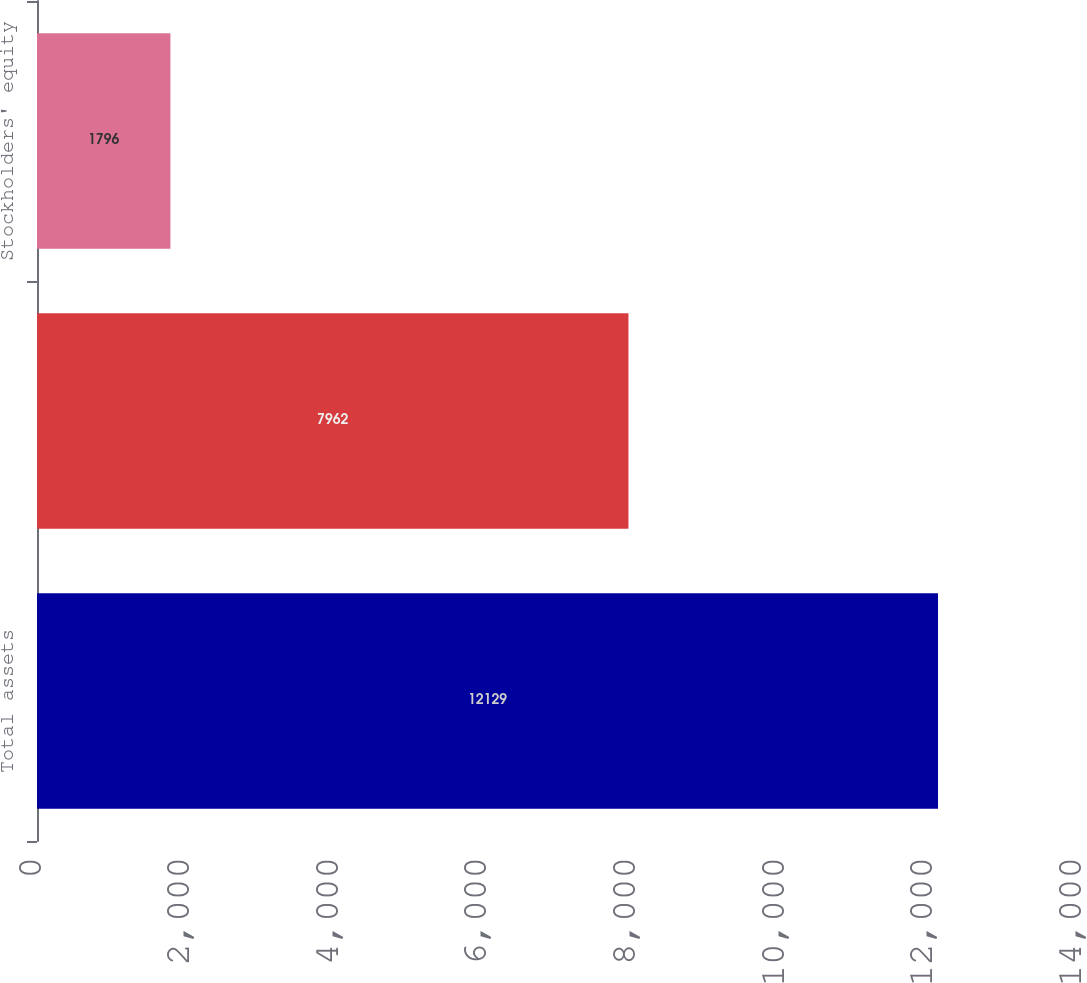Convert chart. <chart><loc_0><loc_0><loc_500><loc_500><bar_chart><fcel>Total assets<fcel>Total debt<fcel>Stockholders' equity<nl><fcel>12129<fcel>7962<fcel>1796<nl></chart> 